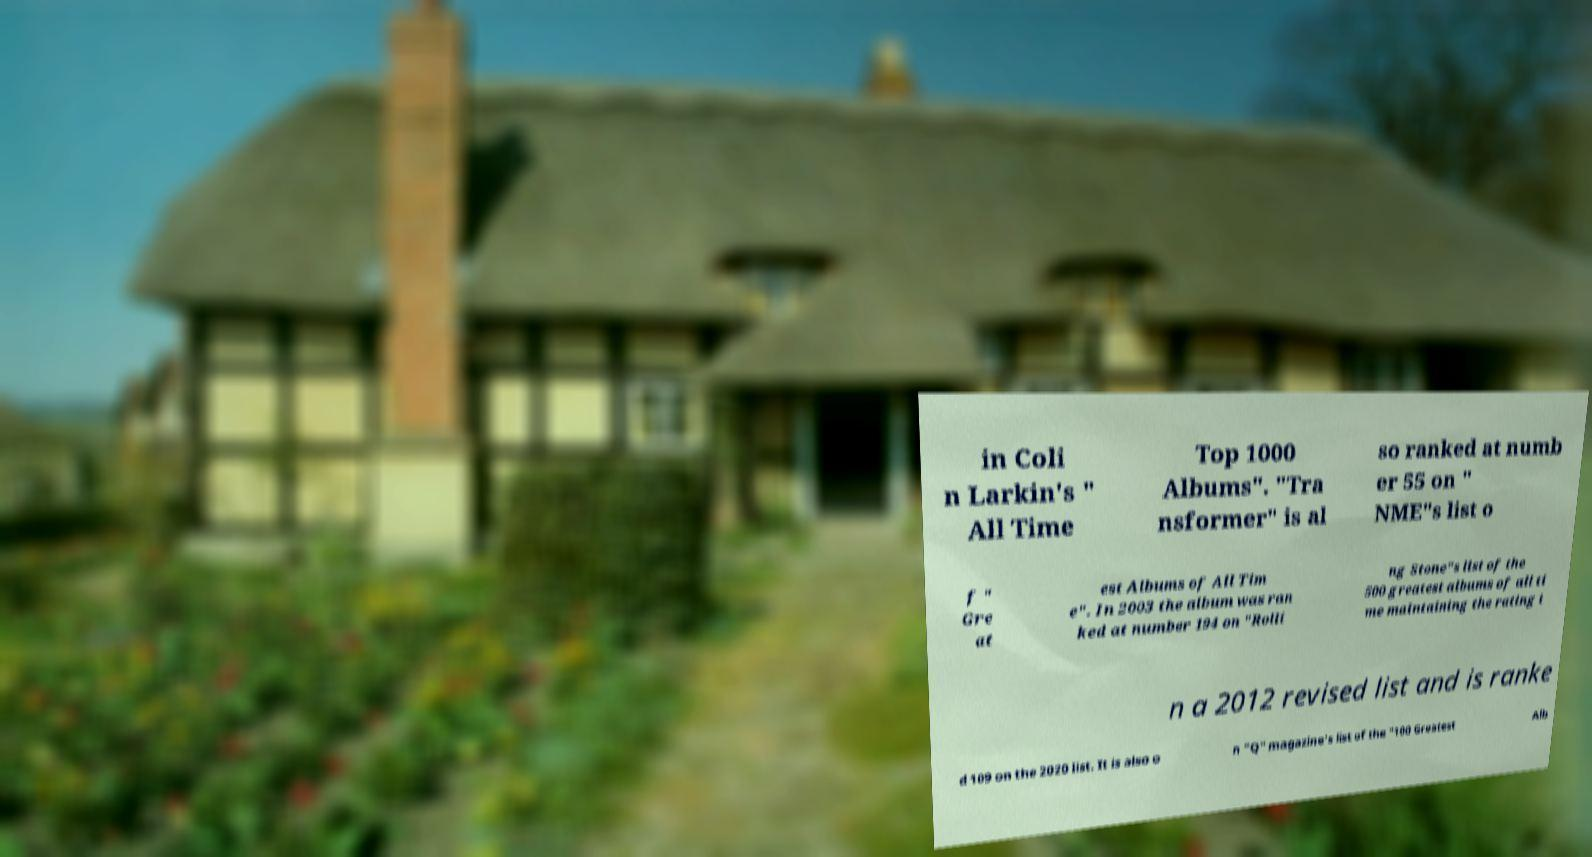Can you accurately transcribe the text from the provided image for me? in Coli n Larkin's " All Time Top 1000 Albums". "Tra nsformer" is al so ranked at numb er 55 on " NME"s list o f " Gre at est Albums of All Tim e". In 2003 the album was ran ked at number 194 on "Rolli ng Stone"s list of the 500 greatest albums of all ti me maintaining the rating i n a 2012 revised list and is ranke d 109 on the 2020 list. It is also o n "Q" magazine's list of the "100 Greatest Alb 